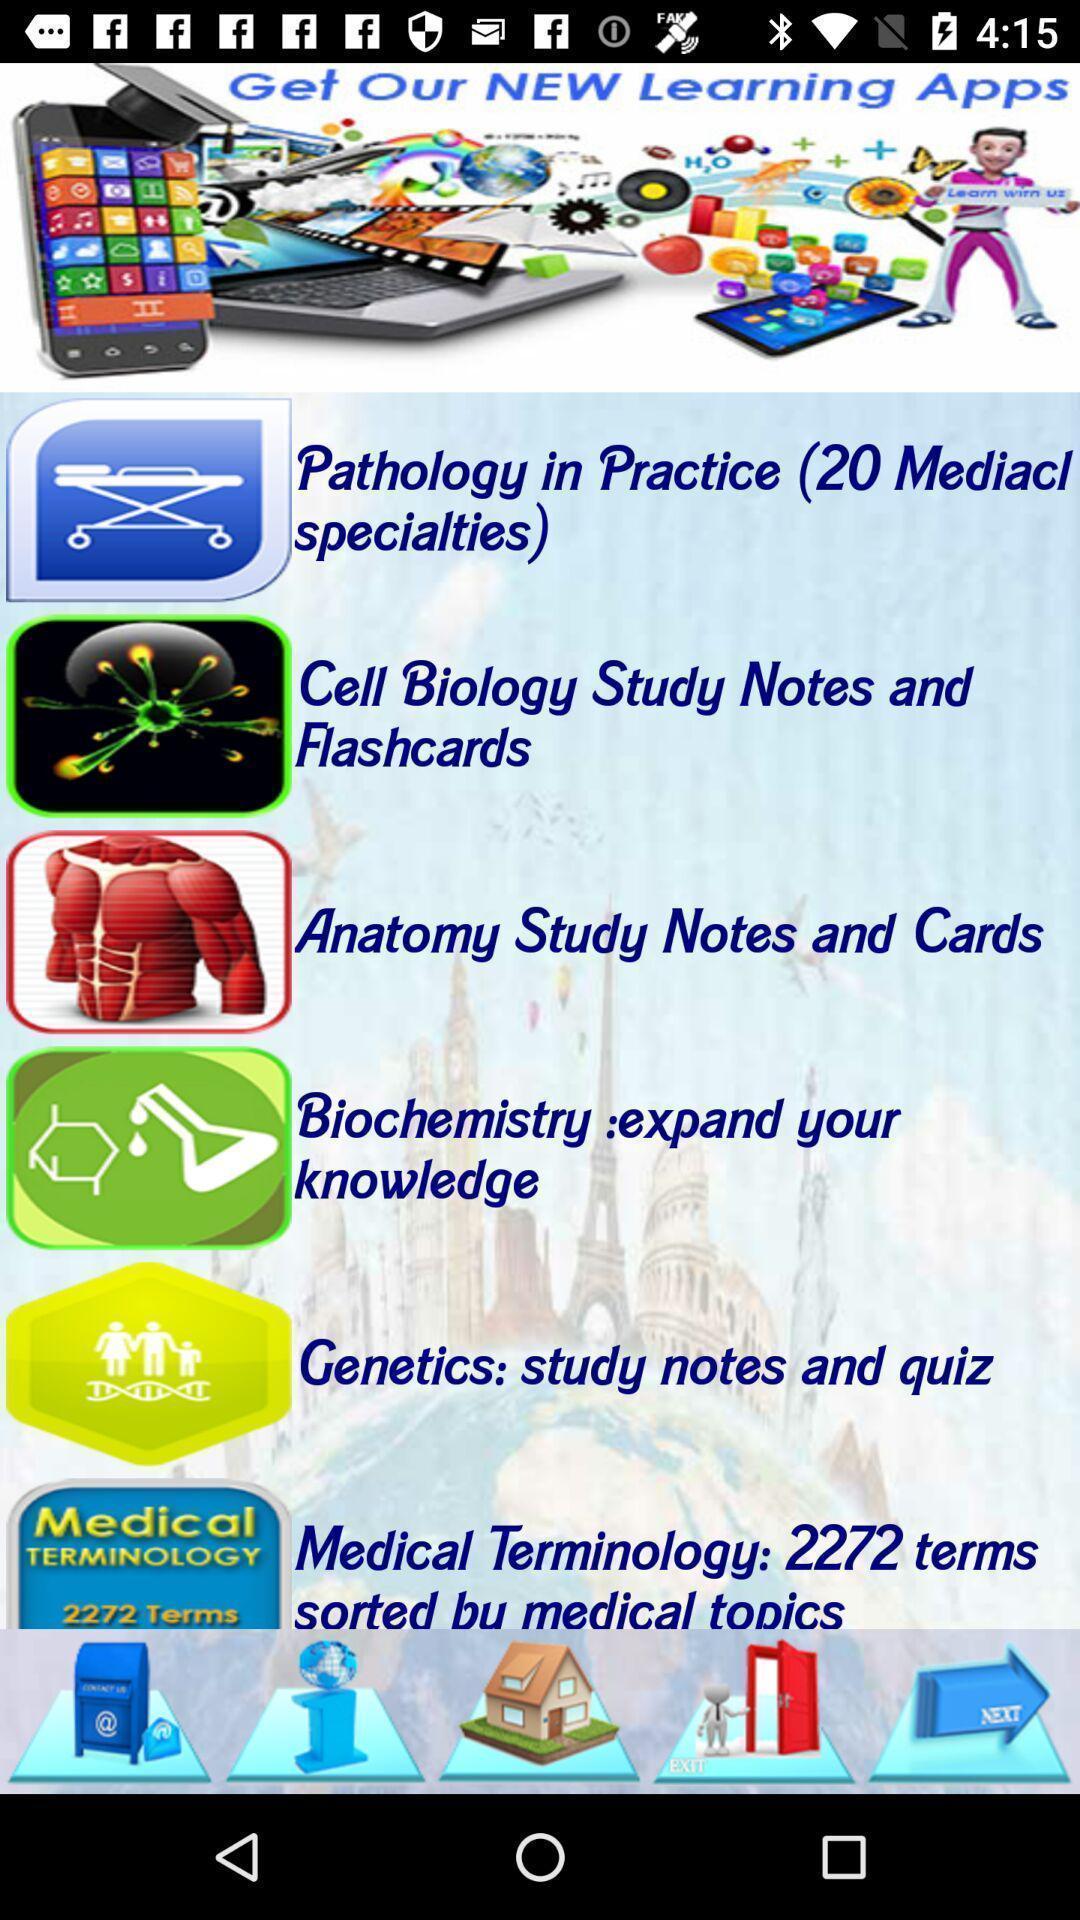Tell me what you see in this picture. Screen displaying multiple topic notes in a learning application. 